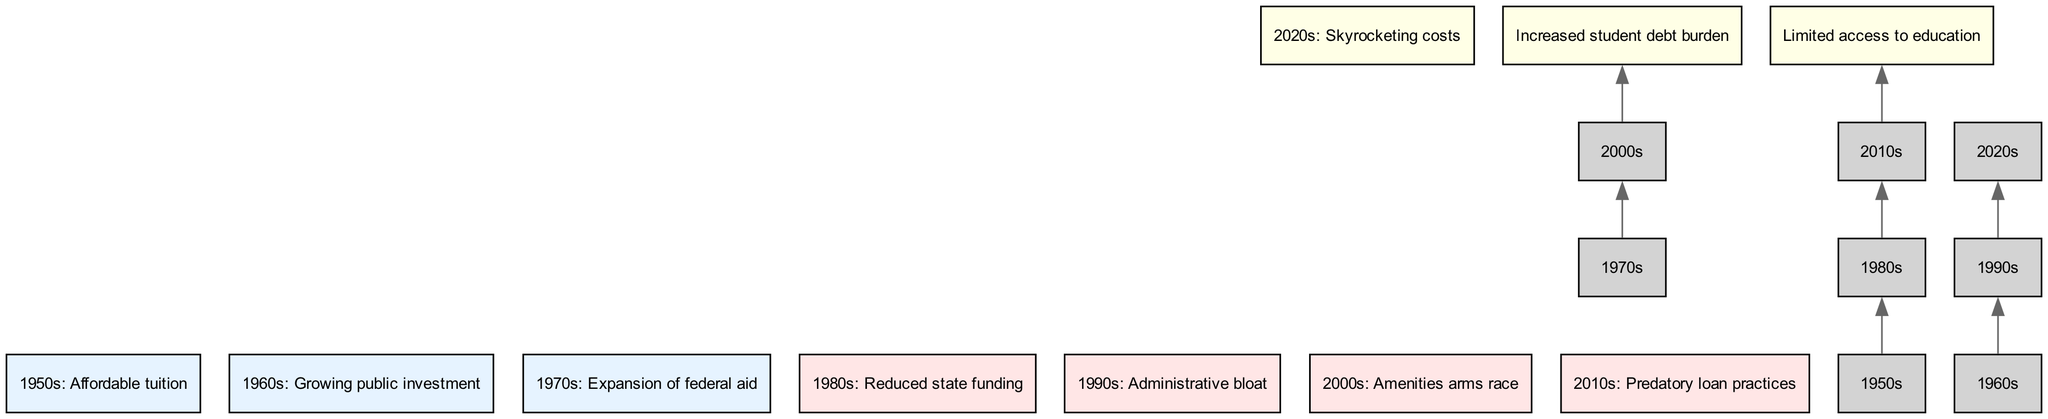What is the starting point in the flow chart? The flow chart begins with the "1950s: Affordable tuition" node, which is the bottommost node representing the initial state of higher education costs.
Answer: 1950s: Affordable tuition How many middle elements are there? There are four middle elements listed in the diagram, representing significant developments that took place between the basic and top layers.
Answer: 4 What is the connection from the 1980s to 2010s? The connection from the "1980s: Reduced state funding" leads to the "2010s: Predatory loan practices," indicating a flow of influence between these two periods.
Answer: 2010s: Predatory loan practices What caused the "Increased student debt burden"? The "Increased student debt burden" is connected to the "2000s: Amenities arms race," suggesting that the arms race for amenities contributed to rising student debt.
Answer: 2000s: Amenities arms race Which decade saw an expansion of federal aid? The "1970s: Expansion of federal aid" is the decade indicated in the flow chart marking this significant development.
Answer: 1970s: Expansion of federal aid What factor directly contributes to costly higher education in the 2020s? The "2020s: Skyrocketing costs" node signifies that various factors have aggregated to rise to this critical level of expense in education.
Answer: Skyrocketing costs Which element connects to the "Limited access to education"? The "Limited access to education" is linked from the "2010s: Predatory loan practices," indicating a direct causal relationship in the chart.
Answer: 2010s: Predatory loan practices What is a major factor in the 1990s affecting higher education costs? The "1990s: Administrative bloat" is a significant factor identified in the middle elements that affected overall education costs during that decade.
Answer: 1990s: Administrative bloat How many top elements are indicated in the diagram? There are three top elements shown in the flow chart, indicating severe consequences and trends in the current state of higher education costs.
Answer: 3 